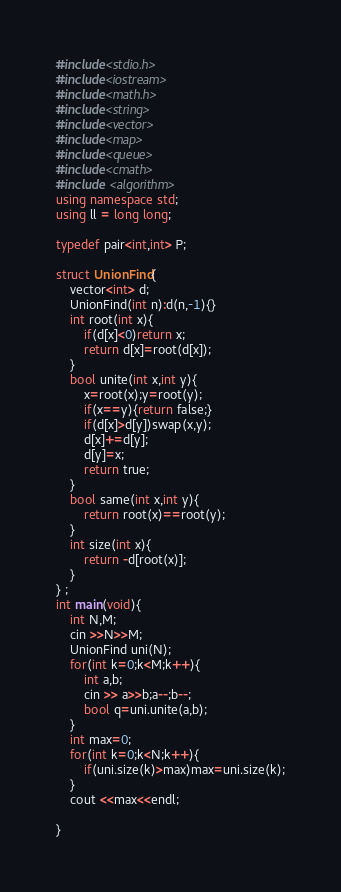Convert code to text. <code><loc_0><loc_0><loc_500><loc_500><_C++_>#include<stdio.h>
#include<iostream>
#include<math.h>
#include<string>
#include<vector>
#include<map>
#include<queue>
#include<cmath>
#include <algorithm>
using namespace std;
using ll = long long;

typedef pair<int,int> P;
 
struct UnionFind{
    vector<int> d;
    UnionFind(int n):d(n,-1){}
    int root(int x){
        if(d[x]<0)return x;
        return d[x]=root(d[x]);
    }
    bool unite(int x,int y){
        x=root(x);y=root(y);
        if(x==y){return false;}
        if(d[x]>d[y])swap(x,y);
        d[x]+=d[y];
        d[y]=x;
        return true;
    }
    bool same(int x,int y){
        return root(x)==root(y);
    }
    int size(int x){
        return -d[root(x)];
    }
} ;
int main(void){
    int N,M;
    cin >>N>>M;
    UnionFind uni(N);
    for(int k=0;k<M;k++){
        int a,b;
        cin >> a>>b;a--;b--;
        bool q=uni.unite(a,b);
    }
    int max=0;
    for(int k=0;k<N;k++){
        if(uni.size(k)>max)max=uni.size(k);
    }
    cout <<max<<endl;

}</code> 